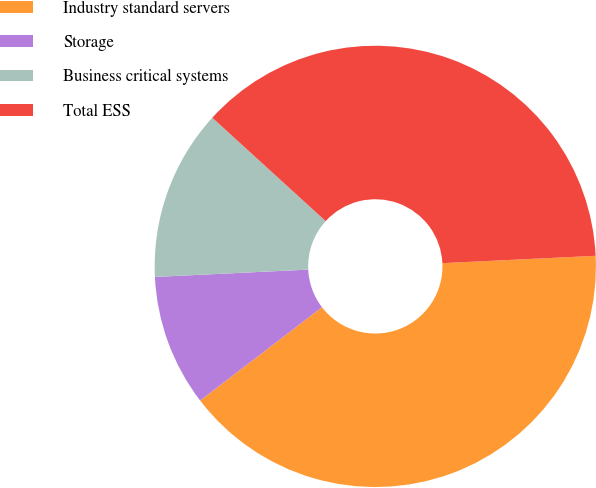Convert chart. <chart><loc_0><loc_0><loc_500><loc_500><pie_chart><fcel>Industry standard servers<fcel>Storage<fcel>Business critical systems<fcel>Total ESS<nl><fcel>40.36%<fcel>9.64%<fcel>12.53%<fcel>37.47%<nl></chart> 